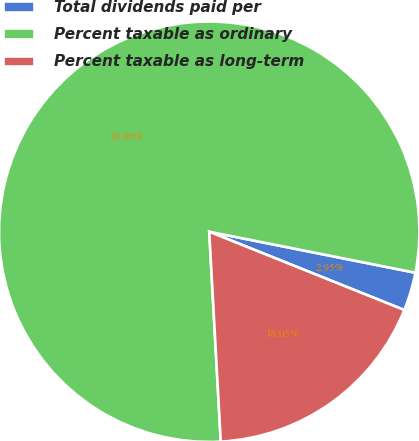<chart> <loc_0><loc_0><loc_500><loc_500><pie_chart><fcel>Total dividends paid per<fcel>Percent taxable as ordinary<fcel>Percent taxable as long-term<nl><fcel>2.95%<fcel>79.0%<fcel>18.05%<nl></chart> 